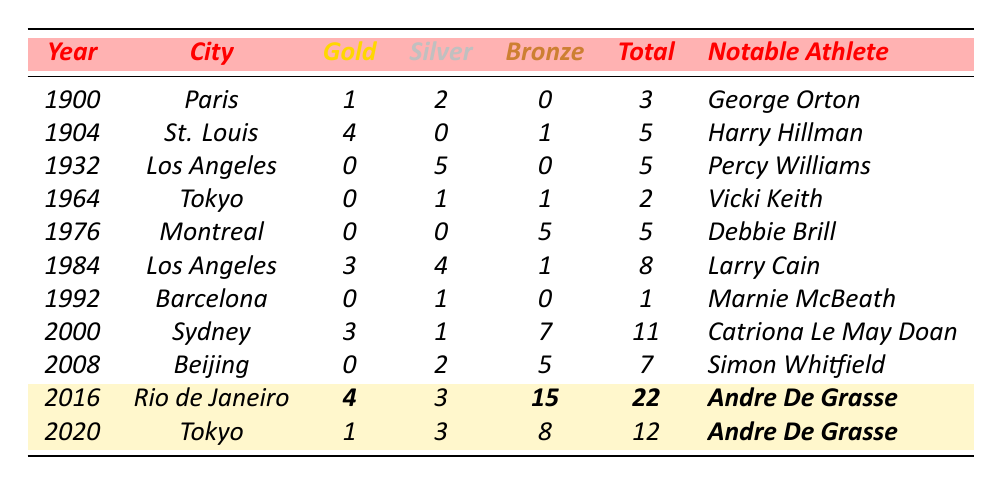What year did Canada win the most total medals? In the table, the year with the highest total medal count is 2016, where Canada won 22 medals.
Answer: 2016 How many gold medals did Canada win in the 1904 Olympics? The table shows that Canada won 4 gold medals in the 1904 Olympics held in St. Louis.
Answer: 4 What is the total number of silver medals Canada earned in the Olympic years listed? Adding the silver medals across all the years: 2 + 0 + 5 + 1 + 0 + 4 + 1 + 1 + 2 + 3 + 3 = 22. Therefore, the total is 22 silver medals.
Answer: 22 In which Olympics did Andre De Grasse win the most medals? By comparing the totals in the years 2016 and 2020, 2016 has a total of 22 medals, while 2020 has 12 medals. Thus, the most medals were won in 2016.
Answer: 2016 How many more bronze medals did Canada win in 2016 compared to 2000? In 2016, Canada won 15 bronze medals, while in 2000, the count was 7. Therefore, the difference is 15 - 7 = 8 bronze medals.
Answer: 8 Did Canada win any gold medals in the 1932 Olympics? The table states that Canada won 0 gold medals in the 1932 Olympics held in Los Angeles. Therefore, the answer is no.
Answer: No What was the average number of gold medals won by Canada from 1900 to 2020? The total number of gold medals won by Canada is: 1 + 4 + 0 + 0 + 0 + 3 + 0 + 3 + 0 + 4 + 1 = 16. Since there are 11 Olympic events listed, the average is 16/11 = approximately 1.45.
Answer: 1.45 Which notable athlete represented Canada in the most recent Olympics listed? The table indicates that Andre De Grasse was the notable athlete for both the 2016 and 2020 Olympics. Hence, he represents Canada in the most recent listed Olympics of 2020.
Answer: Andre De Grasse How many total medals did Canada win in the 2008 Olympics? The table shows that Canada won 7 total medals in the 2008 Olympics held in Beijing.
Answer: 7 Which city hosted the Olympics where Canada won 0 gold medals for the first time? Analyzing the table, the first instance showing 0 gold medals is in the year 1932 in Los Angeles.
Answer: Los Angeles 